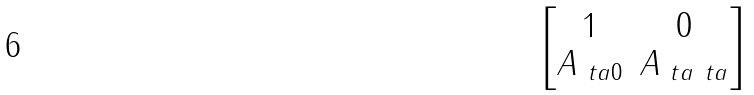<formula> <loc_0><loc_0><loc_500><loc_500>\begin{bmatrix} 1 & 0 \\ A _ { \ t a 0 } & A _ { \ t a \ t a } \end{bmatrix}</formula> 